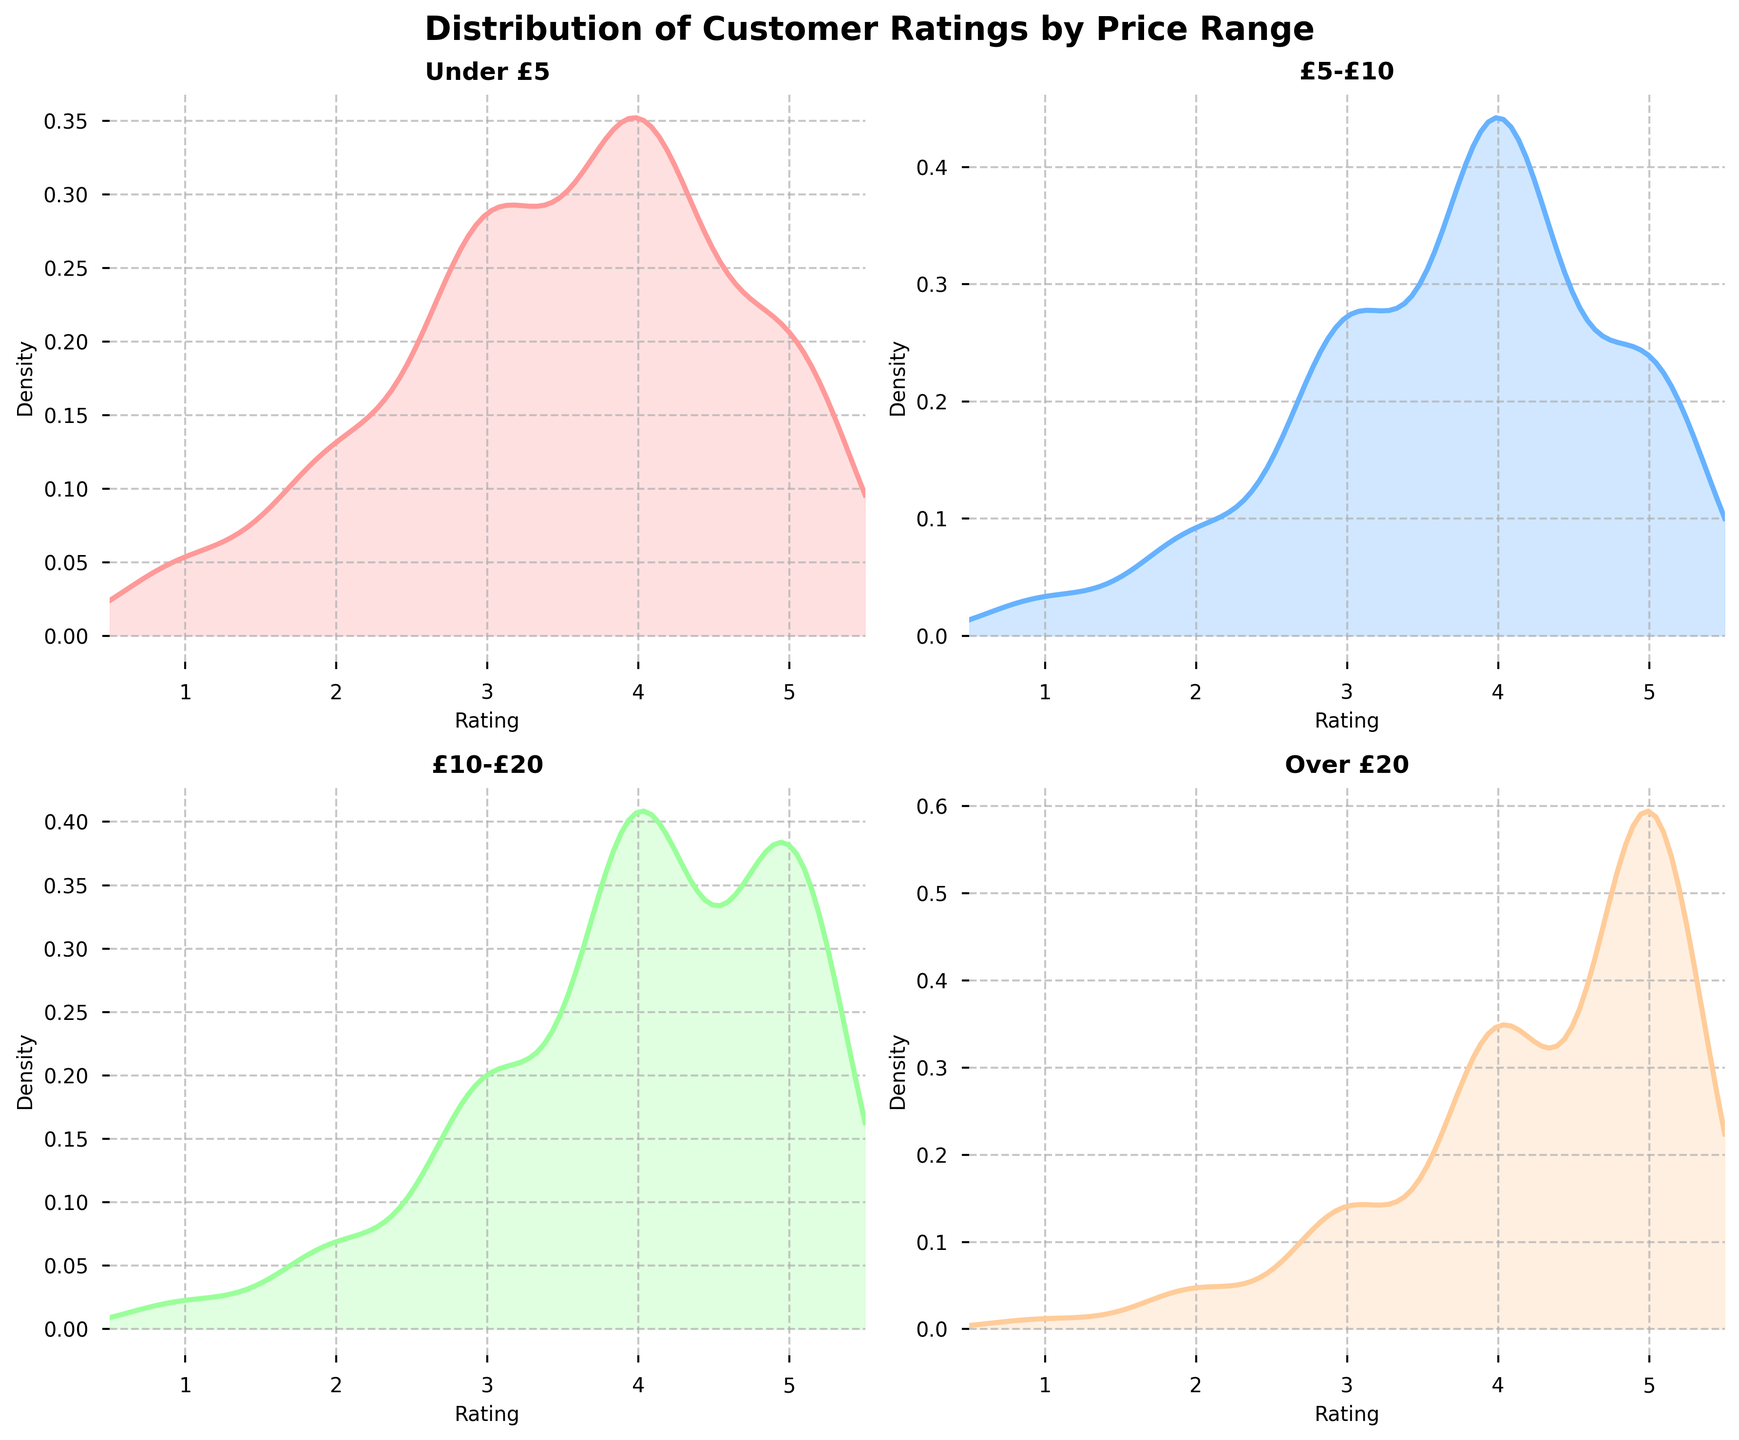What does the title of the plot refer to? The title of the plot is located at the top and summarizes the content of the figure. Here it reads “Distribution of Customer Ratings by Price Range,” indicating that the figure shows how customer ratings are distributed across different book price ranges.
Answer: Distribution of Customer Ratings by Price Range What price range shows the highest density for a rating of 5? To identify the highest density for a rating of 5, look for the peak heights of the density curves at the rating value of 5. The highest peak at 5 is for the "Over £20" price range.
Answer: Over £20 Which price range shows the most symmetric distribution of customer ratings? A symmetric distribution will have a density plot that is roughly mirrored on both sides of a center point. The "£10-£20" price range has a relatively symmetric distribution around the rating of 4.
Answer: £10-£20 Which two price ranges have the most similar curves for customer ratings of 3 and 4? Compare the density plots for each price range, focusing on the intervals around ratings 3 and 4. The "Under £5" and "£5-£10" price ranges have similar shaped curves for these ratings.
Answer: Under £5 and £5-£10 What price range shows a lower density for a rating of 2 compared to a rating of 4? Evaluate the heights of the density curves for the rating of 2 and compare them to the height at rating of 4. All price ranges show this trend, but it is most pronounced in the "£10-£20" range.
Answer: £10-£20 In which price range is the peak of the density curve the highest? To find the highest peak in the density curves, compare the maximum heights of the respective plots for each price range. The peak is highest in the "Over £20" price range for a rating of 5.
Answer: Over £20 How does the distribution of ratings for books priced "Over £20" compare to those priced "Under £5" in terms of skewness? The "Over £20" distribution has a right skew with a higher concentration at ratings 4 and 5, while the "Under £5" distribution is more balanced but slightly right-skewed with a higher density at rating 4.
Answer: "Over £20" is more right-skewed than "Under £5" Which price range has the lowest density for a rating of 3? To find the lowest density for a rating of 3, compare the height of the density curves at the rating value 3. The "Over £20" price range has the lowest density at rating 3.
Answer: Over £20 Is the rating distribution for the "£5-£10" price range unimodal or multimodal? A unimodal distribution has a single peak, while a multimodal distribution has multiple peaks. The "£5-£10" price range has a single evident peak around rating 4, indicating it is unimodal.
Answer: Unimodal 